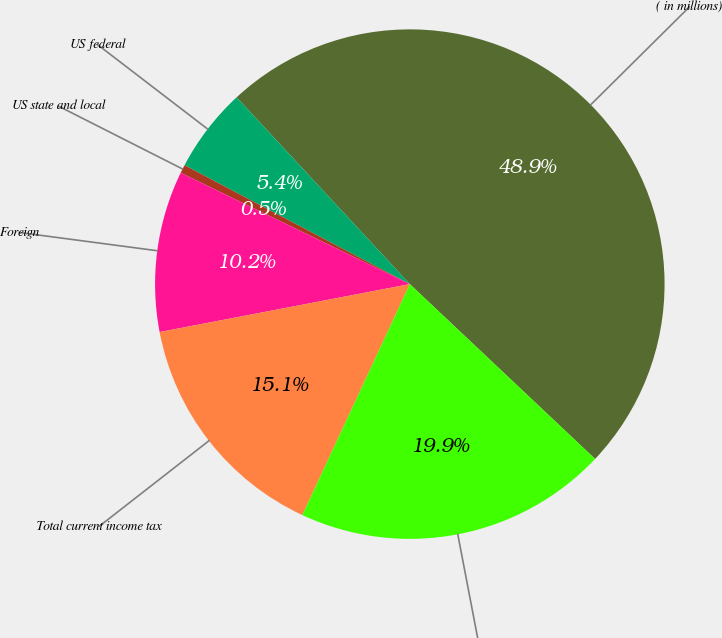Convert chart to OTSL. <chart><loc_0><loc_0><loc_500><loc_500><pie_chart><fcel>( in millions)<fcel>US federal<fcel>US state and local<fcel>Foreign<fcel>Total current income tax<fcel>Total<nl><fcel>48.93%<fcel>5.37%<fcel>0.53%<fcel>10.21%<fcel>15.05%<fcel>19.89%<nl></chart> 